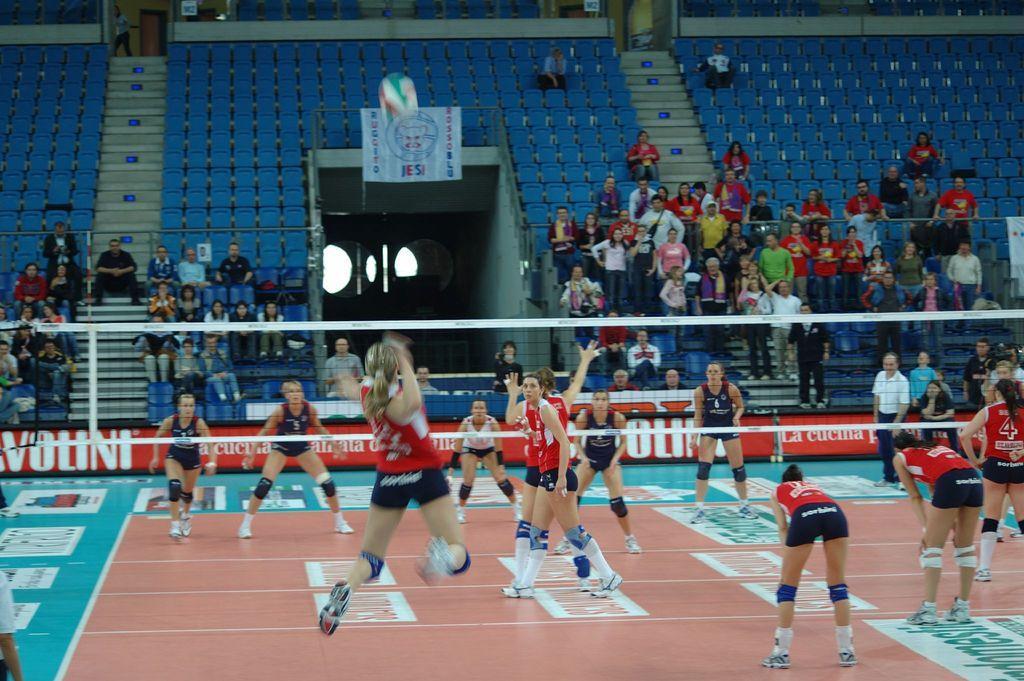Could you give a brief overview of what you see in this image? This picture is taken inside the playground. In this image, we can see a group of people playing a football. In the middle of the image, we can see a net fence. In the background, we can see a few people are sitting on the chair, few people are standing, staircase, hoardings. At the bottom, we can see a floor. 